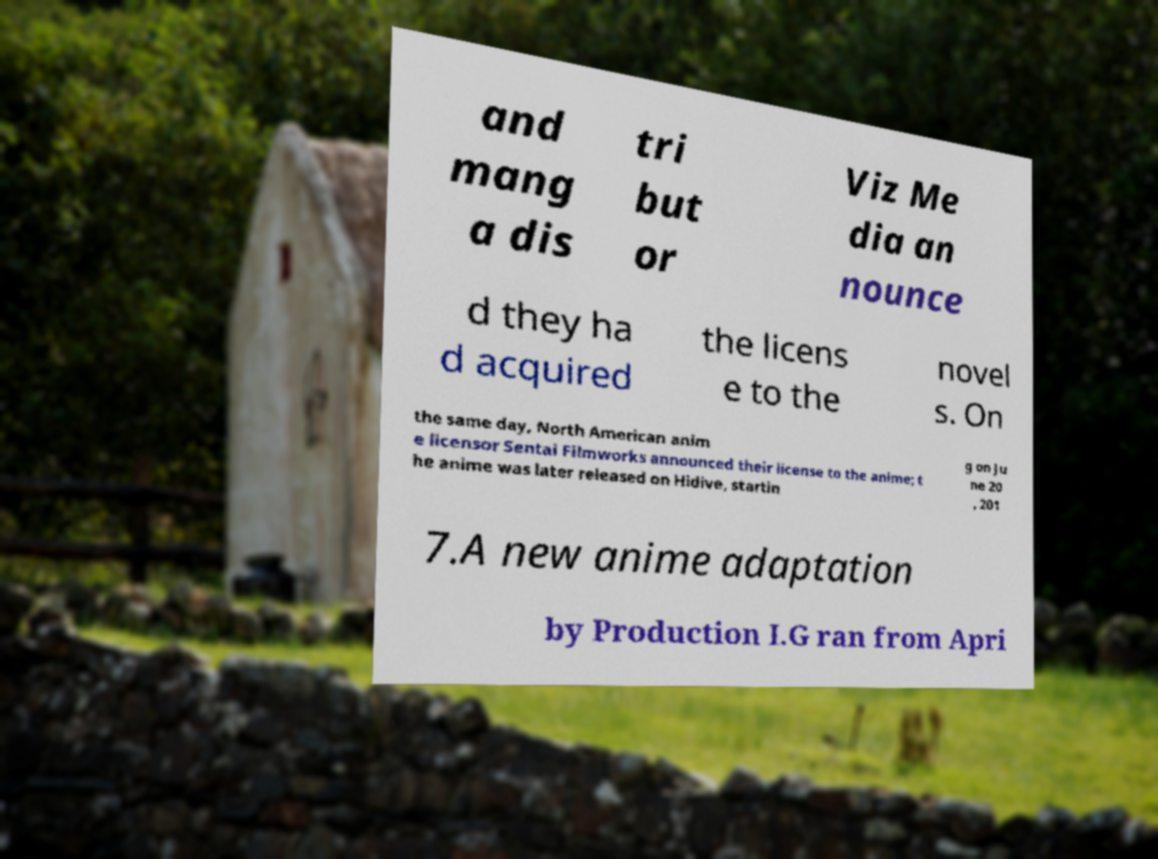I need the written content from this picture converted into text. Can you do that? and mang a dis tri but or Viz Me dia an nounce d they ha d acquired the licens e to the novel s. On the same day, North American anim e licensor Sentai Filmworks announced their license to the anime; t he anime was later released on Hidive, startin g on Ju ne 20 , 201 7.A new anime adaptation by Production I.G ran from Apri 